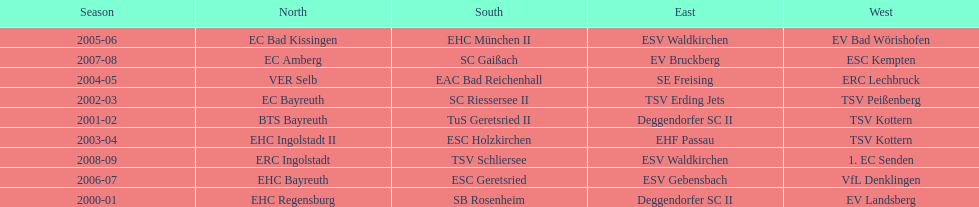How many champions are listend in the north? 9. 